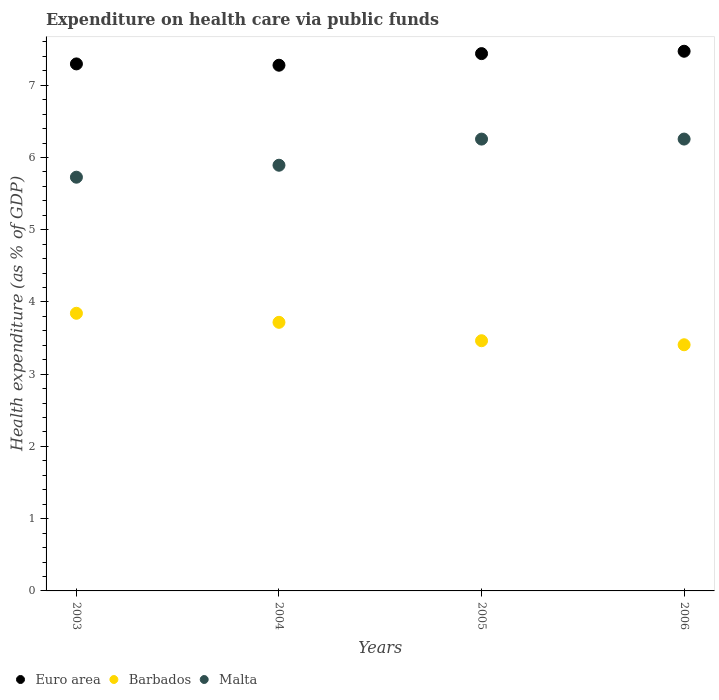Is the number of dotlines equal to the number of legend labels?
Provide a short and direct response. Yes. What is the expenditure made on health care in Euro area in 2004?
Give a very brief answer. 7.28. Across all years, what is the maximum expenditure made on health care in Malta?
Ensure brevity in your answer.  6.25. Across all years, what is the minimum expenditure made on health care in Malta?
Provide a succinct answer. 5.73. In which year was the expenditure made on health care in Euro area maximum?
Offer a very short reply. 2006. What is the total expenditure made on health care in Malta in the graph?
Ensure brevity in your answer.  24.13. What is the difference between the expenditure made on health care in Euro area in 2003 and that in 2004?
Keep it short and to the point. 0.02. What is the difference between the expenditure made on health care in Malta in 2006 and the expenditure made on health care in Euro area in 2003?
Make the answer very short. -1.04. What is the average expenditure made on health care in Euro area per year?
Your response must be concise. 7.37. In the year 2004, what is the difference between the expenditure made on health care in Malta and expenditure made on health care in Barbados?
Offer a terse response. 2.17. What is the ratio of the expenditure made on health care in Euro area in 2003 to that in 2005?
Your answer should be very brief. 0.98. Is the expenditure made on health care in Barbados in 2003 less than that in 2004?
Keep it short and to the point. No. What is the difference between the highest and the second highest expenditure made on health care in Barbados?
Your response must be concise. 0.13. What is the difference between the highest and the lowest expenditure made on health care in Barbados?
Keep it short and to the point. 0.44. Does the graph contain any zero values?
Provide a short and direct response. No. Does the graph contain grids?
Offer a very short reply. No. Where does the legend appear in the graph?
Your response must be concise. Bottom left. How many legend labels are there?
Give a very brief answer. 3. What is the title of the graph?
Ensure brevity in your answer.  Expenditure on health care via public funds. Does "Europe(all income levels)" appear as one of the legend labels in the graph?
Your answer should be very brief. No. What is the label or title of the Y-axis?
Ensure brevity in your answer.  Health expenditure (as % of GDP). What is the Health expenditure (as % of GDP) in Euro area in 2003?
Ensure brevity in your answer.  7.3. What is the Health expenditure (as % of GDP) of Barbados in 2003?
Offer a very short reply. 3.84. What is the Health expenditure (as % of GDP) of Malta in 2003?
Keep it short and to the point. 5.73. What is the Health expenditure (as % of GDP) of Euro area in 2004?
Ensure brevity in your answer.  7.28. What is the Health expenditure (as % of GDP) of Barbados in 2004?
Your answer should be very brief. 3.72. What is the Health expenditure (as % of GDP) in Malta in 2004?
Give a very brief answer. 5.89. What is the Health expenditure (as % of GDP) of Euro area in 2005?
Your answer should be compact. 7.44. What is the Health expenditure (as % of GDP) in Barbados in 2005?
Give a very brief answer. 3.46. What is the Health expenditure (as % of GDP) in Malta in 2005?
Offer a terse response. 6.25. What is the Health expenditure (as % of GDP) in Euro area in 2006?
Ensure brevity in your answer.  7.47. What is the Health expenditure (as % of GDP) in Barbados in 2006?
Offer a very short reply. 3.41. What is the Health expenditure (as % of GDP) in Malta in 2006?
Provide a short and direct response. 6.25. Across all years, what is the maximum Health expenditure (as % of GDP) of Euro area?
Make the answer very short. 7.47. Across all years, what is the maximum Health expenditure (as % of GDP) of Barbados?
Offer a terse response. 3.84. Across all years, what is the maximum Health expenditure (as % of GDP) of Malta?
Provide a short and direct response. 6.25. Across all years, what is the minimum Health expenditure (as % of GDP) in Euro area?
Provide a succinct answer. 7.28. Across all years, what is the minimum Health expenditure (as % of GDP) of Barbados?
Give a very brief answer. 3.41. Across all years, what is the minimum Health expenditure (as % of GDP) of Malta?
Ensure brevity in your answer.  5.73. What is the total Health expenditure (as % of GDP) in Euro area in the graph?
Offer a terse response. 29.48. What is the total Health expenditure (as % of GDP) in Barbados in the graph?
Provide a short and direct response. 14.43. What is the total Health expenditure (as % of GDP) of Malta in the graph?
Provide a succinct answer. 24.13. What is the difference between the Health expenditure (as % of GDP) of Euro area in 2003 and that in 2004?
Offer a terse response. 0.02. What is the difference between the Health expenditure (as % of GDP) of Barbados in 2003 and that in 2004?
Make the answer very short. 0.13. What is the difference between the Health expenditure (as % of GDP) of Malta in 2003 and that in 2004?
Your response must be concise. -0.17. What is the difference between the Health expenditure (as % of GDP) of Euro area in 2003 and that in 2005?
Offer a terse response. -0.14. What is the difference between the Health expenditure (as % of GDP) in Barbados in 2003 and that in 2005?
Your response must be concise. 0.38. What is the difference between the Health expenditure (as % of GDP) of Malta in 2003 and that in 2005?
Provide a short and direct response. -0.53. What is the difference between the Health expenditure (as % of GDP) of Euro area in 2003 and that in 2006?
Make the answer very short. -0.18. What is the difference between the Health expenditure (as % of GDP) of Barbados in 2003 and that in 2006?
Make the answer very short. 0.44. What is the difference between the Health expenditure (as % of GDP) in Malta in 2003 and that in 2006?
Ensure brevity in your answer.  -0.53. What is the difference between the Health expenditure (as % of GDP) in Euro area in 2004 and that in 2005?
Ensure brevity in your answer.  -0.16. What is the difference between the Health expenditure (as % of GDP) in Barbados in 2004 and that in 2005?
Ensure brevity in your answer.  0.25. What is the difference between the Health expenditure (as % of GDP) of Malta in 2004 and that in 2005?
Offer a very short reply. -0.36. What is the difference between the Health expenditure (as % of GDP) in Euro area in 2004 and that in 2006?
Give a very brief answer. -0.19. What is the difference between the Health expenditure (as % of GDP) of Barbados in 2004 and that in 2006?
Offer a terse response. 0.31. What is the difference between the Health expenditure (as % of GDP) in Malta in 2004 and that in 2006?
Provide a short and direct response. -0.36. What is the difference between the Health expenditure (as % of GDP) of Euro area in 2005 and that in 2006?
Provide a succinct answer. -0.03. What is the difference between the Health expenditure (as % of GDP) in Barbados in 2005 and that in 2006?
Keep it short and to the point. 0.06. What is the difference between the Health expenditure (as % of GDP) in Malta in 2005 and that in 2006?
Your answer should be compact. -0. What is the difference between the Health expenditure (as % of GDP) of Euro area in 2003 and the Health expenditure (as % of GDP) of Barbados in 2004?
Your response must be concise. 3.58. What is the difference between the Health expenditure (as % of GDP) in Euro area in 2003 and the Health expenditure (as % of GDP) in Malta in 2004?
Make the answer very short. 1.4. What is the difference between the Health expenditure (as % of GDP) in Barbados in 2003 and the Health expenditure (as % of GDP) in Malta in 2004?
Your response must be concise. -2.05. What is the difference between the Health expenditure (as % of GDP) of Euro area in 2003 and the Health expenditure (as % of GDP) of Barbados in 2005?
Ensure brevity in your answer.  3.83. What is the difference between the Health expenditure (as % of GDP) of Euro area in 2003 and the Health expenditure (as % of GDP) of Malta in 2005?
Your answer should be compact. 1.04. What is the difference between the Health expenditure (as % of GDP) in Barbados in 2003 and the Health expenditure (as % of GDP) in Malta in 2005?
Offer a terse response. -2.41. What is the difference between the Health expenditure (as % of GDP) in Euro area in 2003 and the Health expenditure (as % of GDP) in Barbados in 2006?
Your answer should be compact. 3.89. What is the difference between the Health expenditure (as % of GDP) of Euro area in 2003 and the Health expenditure (as % of GDP) of Malta in 2006?
Ensure brevity in your answer.  1.04. What is the difference between the Health expenditure (as % of GDP) of Barbados in 2003 and the Health expenditure (as % of GDP) of Malta in 2006?
Ensure brevity in your answer.  -2.41. What is the difference between the Health expenditure (as % of GDP) in Euro area in 2004 and the Health expenditure (as % of GDP) in Barbados in 2005?
Provide a succinct answer. 3.81. What is the difference between the Health expenditure (as % of GDP) of Euro area in 2004 and the Health expenditure (as % of GDP) of Malta in 2005?
Provide a short and direct response. 1.02. What is the difference between the Health expenditure (as % of GDP) of Barbados in 2004 and the Health expenditure (as % of GDP) of Malta in 2005?
Offer a very short reply. -2.54. What is the difference between the Health expenditure (as % of GDP) of Euro area in 2004 and the Health expenditure (as % of GDP) of Barbados in 2006?
Offer a very short reply. 3.87. What is the difference between the Health expenditure (as % of GDP) in Euro area in 2004 and the Health expenditure (as % of GDP) in Malta in 2006?
Provide a short and direct response. 1.02. What is the difference between the Health expenditure (as % of GDP) of Barbados in 2004 and the Health expenditure (as % of GDP) of Malta in 2006?
Give a very brief answer. -2.54. What is the difference between the Health expenditure (as % of GDP) of Euro area in 2005 and the Health expenditure (as % of GDP) of Barbados in 2006?
Offer a terse response. 4.03. What is the difference between the Health expenditure (as % of GDP) of Euro area in 2005 and the Health expenditure (as % of GDP) of Malta in 2006?
Provide a short and direct response. 1.18. What is the difference between the Health expenditure (as % of GDP) of Barbados in 2005 and the Health expenditure (as % of GDP) of Malta in 2006?
Your answer should be compact. -2.79. What is the average Health expenditure (as % of GDP) of Euro area per year?
Provide a short and direct response. 7.37. What is the average Health expenditure (as % of GDP) in Barbados per year?
Offer a terse response. 3.61. What is the average Health expenditure (as % of GDP) in Malta per year?
Give a very brief answer. 6.03. In the year 2003, what is the difference between the Health expenditure (as % of GDP) in Euro area and Health expenditure (as % of GDP) in Barbados?
Your answer should be very brief. 3.45. In the year 2003, what is the difference between the Health expenditure (as % of GDP) in Euro area and Health expenditure (as % of GDP) in Malta?
Your answer should be very brief. 1.57. In the year 2003, what is the difference between the Health expenditure (as % of GDP) of Barbados and Health expenditure (as % of GDP) of Malta?
Your response must be concise. -1.88. In the year 2004, what is the difference between the Health expenditure (as % of GDP) of Euro area and Health expenditure (as % of GDP) of Barbados?
Make the answer very short. 3.56. In the year 2004, what is the difference between the Health expenditure (as % of GDP) in Euro area and Health expenditure (as % of GDP) in Malta?
Ensure brevity in your answer.  1.38. In the year 2004, what is the difference between the Health expenditure (as % of GDP) of Barbados and Health expenditure (as % of GDP) of Malta?
Provide a short and direct response. -2.17. In the year 2005, what is the difference between the Health expenditure (as % of GDP) in Euro area and Health expenditure (as % of GDP) in Barbados?
Your response must be concise. 3.97. In the year 2005, what is the difference between the Health expenditure (as % of GDP) in Euro area and Health expenditure (as % of GDP) in Malta?
Your answer should be compact. 1.18. In the year 2005, what is the difference between the Health expenditure (as % of GDP) in Barbados and Health expenditure (as % of GDP) in Malta?
Offer a very short reply. -2.79. In the year 2006, what is the difference between the Health expenditure (as % of GDP) in Euro area and Health expenditure (as % of GDP) in Barbados?
Your answer should be compact. 4.06. In the year 2006, what is the difference between the Health expenditure (as % of GDP) in Euro area and Health expenditure (as % of GDP) in Malta?
Your answer should be very brief. 1.22. In the year 2006, what is the difference between the Health expenditure (as % of GDP) of Barbados and Health expenditure (as % of GDP) of Malta?
Provide a short and direct response. -2.85. What is the ratio of the Health expenditure (as % of GDP) of Euro area in 2003 to that in 2004?
Offer a terse response. 1. What is the ratio of the Health expenditure (as % of GDP) of Barbados in 2003 to that in 2004?
Offer a terse response. 1.03. What is the ratio of the Health expenditure (as % of GDP) of Malta in 2003 to that in 2004?
Your response must be concise. 0.97. What is the ratio of the Health expenditure (as % of GDP) of Euro area in 2003 to that in 2005?
Provide a short and direct response. 0.98. What is the ratio of the Health expenditure (as % of GDP) in Barbados in 2003 to that in 2005?
Ensure brevity in your answer.  1.11. What is the ratio of the Health expenditure (as % of GDP) in Malta in 2003 to that in 2005?
Keep it short and to the point. 0.92. What is the ratio of the Health expenditure (as % of GDP) of Euro area in 2003 to that in 2006?
Your answer should be compact. 0.98. What is the ratio of the Health expenditure (as % of GDP) of Barbados in 2003 to that in 2006?
Make the answer very short. 1.13. What is the ratio of the Health expenditure (as % of GDP) of Malta in 2003 to that in 2006?
Offer a very short reply. 0.92. What is the ratio of the Health expenditure (as % of GDP) in Euro area in 2004 to that in 2005?
Your response must be concise. 0.98. What is the ratio of the Health expenditure (as % of GDP) of Barbados in 2004 to that in 2005?
Ensure brevity in your answer.  1.07. What is the ratio of the Health expenditure (as % of GDP) in Malta in 2004 to that in 2005?
Ensure brevity in your answer.  0.94. What is the ratio of the Health expenditure (as % of GDP) in Euro area in 2004 to that in 2006?
Keep it short and to the point. 0.97. What is the ratio of the Health expenditure (as % of GDP) in Barbados in 2004 to that in 2006?
Ensure brevity in your answer.  1.09. What is the ratio of the Health expenditure (as % of GDP) of Malta in 2004 to that in 2006?
Ensure brevity in your answer.  0.94. What is the ratio of the Health expenditure (as % of GDP) in Barbados in 2005 to that in 2006?
Provide a short and direct response. 1.02. What is the ratio of the Health expenditure (as % of GDP) in Malta in 2005 to that in 2006?
Keep it short and to the point. 1. What is the difference between the highest and the second highest Health expenditure (as % of GDP) of Euro area?
Provide a short and direct response. 0.03. What is the difference between the highest and the second highest Health expenditure (as % of GDP) of Barbados?
Provide a short and direct response. 0.13. What is the difference between the highest and the second highest Health expenditure (as % of GDP) in Malta?
Provide a short and direct response. 0. What is the difference between the highest and the lowest Health expenditure (as % of GDP) of Euro area?
Ensure brevity in your answer.  0.19. What is the difference between the highest and the lowest Health expenditure (as % of GDP) of Barbados?
Your response must be concise. 0.44. What is the difference between the highest and the lowest Health expenditure (as % of GDP) in Malta?
Keep it short and to the point. 0.53. 